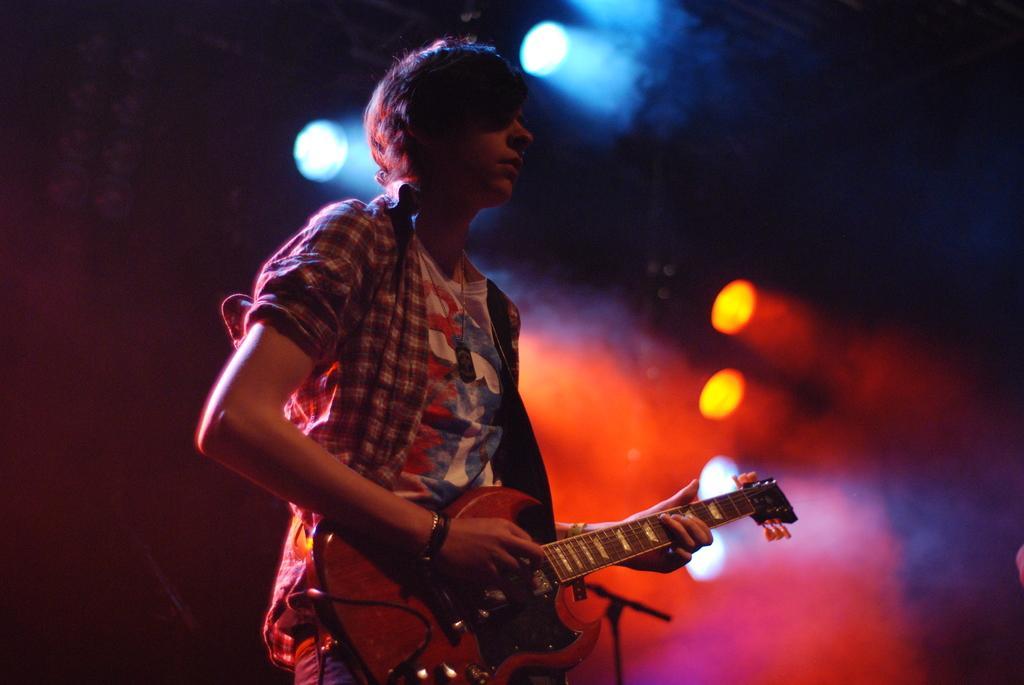In one or two sentences, can you explain what this image depicts? In this image i can see a man standing and holding guitar at the background i can see few lights. 